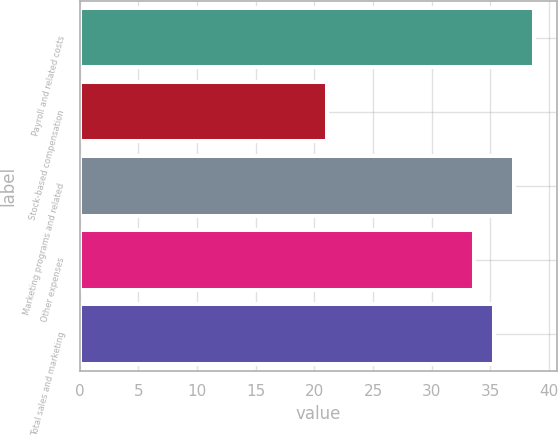Convert chart to OTSL. <chart><loc_0><loc_0><loc_500><loc_500><bar_chart><fcel>Payroll and related costs<fcel>Stock-based compensation<fcel>Marketing programs and related<fcel>Other expenses<fcel>Total sales and marketing<nl><fcel>38.73<fcel>21.1<fcel>37.02<fcel>33.6<fcel>35.31<nl></chart> 